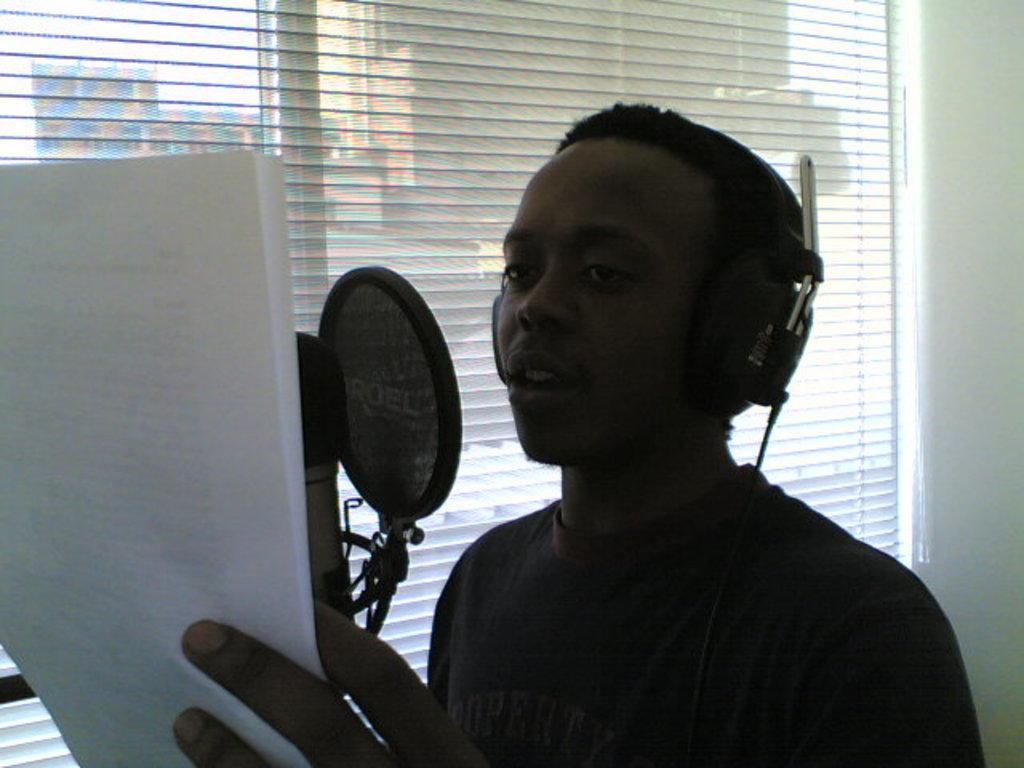Please provide a concise description of this image. In the foreground of this image, there is a man wearing headset and holding a paper in front of a microphone net and a mic. In the background, there is a window blind and the wall. 